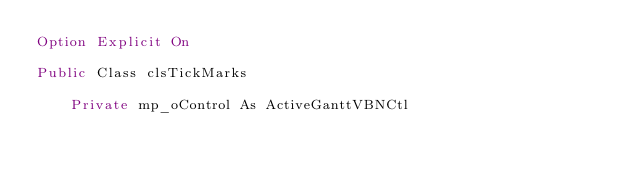<code> <loc_0><loc_0><loc_500><loc_500><_VisualBasic_>Option Explicit On 

Public Class clsTickMarks

    Private mp_oControl As ActiveGanttVBNCtl</code> 